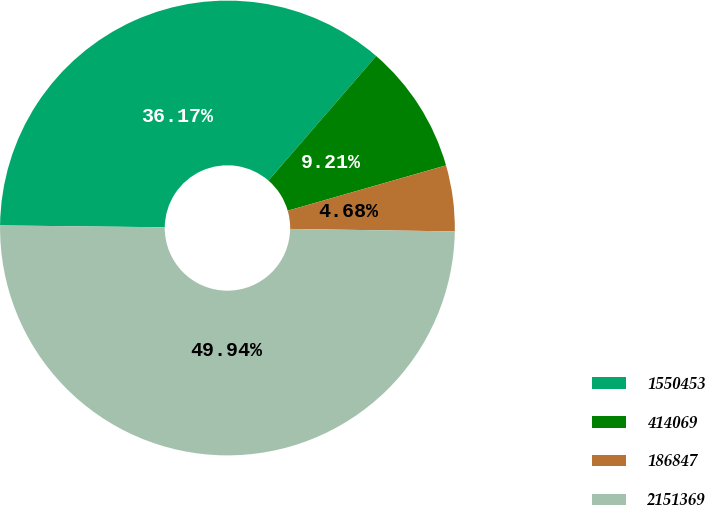Convert chart. <chart><loc_0><loc_0><loc_500><loc_500><pie_chart><fcel>1550453<fcel>414069<fcel>186847<fcel>2151369<nl><fcel>36.17%<fcel>9.21%<fcel>4.68%<fcel>49.94%<nl></chart> 